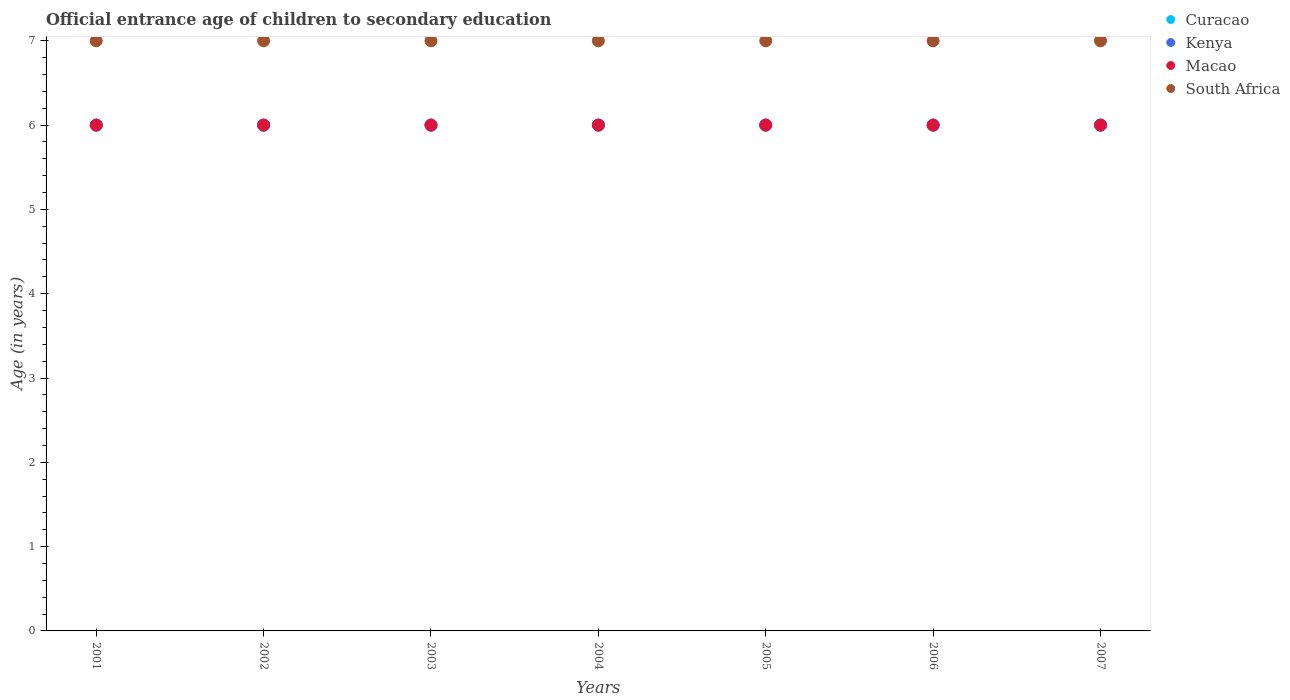How many different coloured dotlines are there?
Ensure brevity in your answer.  4. What is the secondary school starting age of children in Macao in 2005?
Offer a very short reply. 6. Across all years, what is the maximum secondary school starting age of children in Curacao?
Make the answer very short. 6. Across all years, what is the minimum secondary school starting age of children in Kenya?
Make the answer very short. 6. In which year was the secondary school starting age of children in Macao maximum?
Keep it short and to the point. 2001. What is the total secondary school starting age of children in Macao in the graph?
Your answer should be very brief. 42. What is the difference between the secondary school starting age of children in Kenya in 2001 and that in 2004?
Provide a short and direct response. 0. What is the average secondary school starting age of children in South Africa per year?
Give a very brief answer. 7. In the year 2006, what is the difference between the secondary school starting age of children in Curacao and secondary school starting age of children in Macao?
Provide a succinct answer. 0. In how many years, is the secondary school starting age of children in South Africa greater than 4.8 years?
Ensure brevity in your answer.  7. Is the difference between the secondary school starting age of children in Curacao in 2001 and 2007 greater than the difference between the secondary school starting age of children in Macao in 2001 and 2007?
Offer a very short reply. No. What is the difference between the highest and the second highest secondary school starting age of children in Kenya?
Give a very brief answer. 0. Is it the case that in every year, the sum of the secondary school starting age of children in South Africa and secondary school starting age of children in Macao  is greater than the sum of secondary school starting age of children in Kenya and secondary school starting age of children in Curacao?
Make the answer very short. Yes. Is the secondary school starting age of children in Kenya strictly greater than the secondary school starting age of children in South Africa over the years?
Provide a succinct answer. No. Is the secondary school starting age of children in Kenya strictly less than the secondary school starting age of children in Macao over the years?
Your answer should be very brief. No. Are the values on the major ticks of Y-axis written in scientific E-notation?
Your answer should be compact. No. How many legend labels are there?
Your answer should be compact. 4. What is the title of the graph?
Provide a short and direct response. Official entrance age of children to secondary education. What is the label or title of the Y-axis?
Provide a succinct answer. Age (in years). What is the Age (in years) in Curacao in 2001?
Keep it short and to the point. 6. What is the Age (in years) of South Africa in 2001?
Make the answer very short. 7. What is the Age (in years) of Curacao in 2002?
Offer a very short reply. 6. What is the Age (in years) of Kenya in 2002?
Provide a short and direct response. 6. What is the Age (in years) of South Africa in 2002?
Offer a terse response. 7. What is the Age (in years) of Curacao in 2003?
Give a very brief answer. 6. What is the Age (in years) of Macao in 2003?
Make the answer very short. 6. What is the Age (in years) of South Africa in 2004?
Your response must be concise. 7. What is the Age (in years) of Curacao in 2006?
Provide a short and direct response. 6. What is the Age (in years) in South Africa in 2006?
Your answer should be compact. 7. What is the Age (in years) of South Africa in 2007?
Keep it short and to the point. 7. Across all years, what is the maximum Age (in years) in Curacao?
Keep it short and to the point. 6. Across all years, what is the minimum Age (in years) in Macao?
Provide a short and direct response. 6. What is the total Age (in years) of Curacao in the graph?
Ensure brevity in your answer.  42. What is the total Age (in years) of Macao in the graph?
Offer a terse response. 42. What is the difference between the Age (in years) in Curacao in 2001 and that in 2002?
Give a very brief answer. 0. What is the difference between the Age (in years) in Kenya in 2001 and that in 2002?
Keep it short and to the point. 0. What is the difference between the Age (in years) in Kenya in 2001 and that in 2003?
Ensure brevity in your answer.  0. What is the difference between the Age (in years) in South Africa in 2001 and that in 2003?
Provide a succinct answer. 0. What is the difference between the Age (in years) in Macao in 2001 and that in 2004?
Provide a succinct answer. 0. What is the difference between the Age (in years) of South Africa in 2001 and that in 2004?
Give a very brief answer. 0. What is the difference between the Age (in years) of South Africa in 2001 and that in 2005?
Give a very brief answer. 0. What is the difference between the Age (in years) of Curacao in 2001 and that in 2006?
Give a very brief answer. 0. What is the difference between the Age (in years) of Kenya in 2001 and that in 2007?
Offer a terse response. 0. What is the difference between the Age (in years) in Macao in 2001 and that in 2007?
Offer a terse response. 0. What is the difference between the Age (in years) in Kenya in 2002 and that in 2003?
Offer a terse response. 0. What is the difference between the Age (in years) in Kenya in 2002 and that in 2004?
Your response must be concise. 0. What is the difference between the Age (in years) in Macao in 2002 and that in 2004?
Keep it short and to the point. 0. What is the difference between the Age (in years) in Curacao in 2002 and that in 2005?
Ensure brevity in your answer.  0. What is the difference between the Age (in years) of South Africa in 2002 and that in 2005?
Your response must be concise. 0. What is the difference between the Age (in years) in Curacao in 2002 and that in 2006?
Give a very brief answer. 0. What is the difference between the Age (in years) of Macao in 2002 and that in 2006?
Ensure brevity in your answer.  0. What is the difference between the Age (in years) in Macao in 2002 and that in 2007?
Ensure brevity in your answer.  0. What is the difference between the Age (in years) in South Africa in 2002 and that in 2007?
Your answer should be compact. 0. What is the difference between the Age (in years) of Curacao in 2003 and that in 2004?
Keep it short and to the point. 0. What is the difference between the Age (in years) of Curacao in 2003 and that in 2005?
Offer a very short reply. 0. What is the difference between the Age (in years) of Kenya in 2003 and that in 2005?
Give a very brief answer. 0. What is the difference between the Age (in years) in Macao in 2003 and that in 2005?
Provide a short and direct response. 0. What is the difference between the Age (in years) of South Africa in 2003 and that in 2005?
Offer a terse response. 0. What is the difference between the Age (in years) of Curacao in 2003 and that in 2006?
Offer a very short reply. 0. What is the difference between the Age (in years) of Macao in 2003 and that in 2007?
Your answer should be very brief. 0. What is the difference between the Age (in years) of South Africa in 2003 and that in 2007?
Make the answer very short. 0. What is the difference between the Age (in years) of Curacao in 2004 and that in 2005?
Provide a short and direct response. 0. What is the difference between the Age (in years) in Kenya in 2004 and that in 2005?
Your answer should be very brief. 0. What is the difference between the Age (in years) in Macao in 2004 and that in 2005?
Give a very brief answer. 0. What is the difference between the Age (in years) of Curacao in 2004 and that in 2006?
Ensure brevity in your answer.  0. What is the difference between the Age (in years) of Kenya in 2004 and that in 2006?
Keep it short and to the point. 0. What is the difference between the Age (in years) of Macao in 2004 and that in 2006?
Ensure brevity in your answer.  0. What is the difference between the Age (in years) of South Africa in 2004 and that in 2006?
Provide a succinct answer. 0. What is the difference between the Age (in years) of Kenya in 2004 and that in 2007?
Make the answer very short. 0. What is the difference between the Age (in years) of Curacao in 2005 and that in 2006?
Provide a succinct answer. 0. What is the difference between the Age (in years) of Kenya in 2005 and that in 2006?
Offer a very short reply. 0. What is the difference between the Age (in years) of South Africa in 2005 and that in 2006?
Keep it short and to the point. 0. What is the difference between the Age (in years) of Curacao in 2005 and that in 2007?
Your answer should be very brief. 0. What is the difference between the Age (in years) in Curacao in 2006 and that in 2007?
Keep it short and to the point. 0. What is the difference between the Age (in years) in South Africa in 2006 and that in 2007?
Your response must be concise. 0. What is the difference between the Age (in years) in Curacao in 2001 and the Age (in years) in Kenya in 2002?
Your answer should be very brief. 0. What is the difference between the Age (in years) in Curacao in 2001 and the Age (in years) in Macao in 2002?
Ensure brevity in your answer.  0. What is the difference between the Age (in years) in Kenya in 2001 and the Age (in years) in Macao in 2002?
Your answer should be very brief. 0. What is the difference between the Age (in years) of Curacao in 2001 and the Age (in years) of Kenya in 2003?
Offer a very short reply. 0. What is the difference between the Age (in years) in Curacao in 2001 and the Age (in years) in Macao in 2003?
Make the answer very short. 0. What is the difference between the Age (in years) in Macao in 2001 and the Age (in years) in South Africa in 2003?
Give a very brief answer. -1. What is the difference between the Age (in years) in Curacao in 2001 and the Age (in years) in Macao in 2004?
Provide a succinct answer. 0. What is the difference between the Age (in years) of Curacao in 2001 and the Age (in years) of South Africa in 2004?
Provide a short and direct response. -1. What is the difference between the Age (in years) in Kenya in 2001 and the Age (in years) in Macao in 2004?
Ensure brevity in your answer.  0. What is the difference between the Age (in years) of Curacao in 2001 and the Age (in years) of Kenya in 2005?
Give a very brief answer. 0. What is the difference between the Age (in years) in Kenya in 2001 and the Age (in years) in Macao in 2005?
Make the answer very short. 0. What is the difference between the Age (in years) in Macao in 2001 and the Age (in years) in South Africa in 2005?
Provide a succinct answer. -1. What is the difference between the Age (in years) in Curacao in 2001 and the Age (in years) in Macao in 2006?
Your response must be concise. 0. What is the difference between the Age (in years) of Curacao in 2001 and the Age (in years) of South Africa in 2006?
Offer a very short reply. -1. What is the difference between the Age (in years) of Kenya in 2001 and the Age (in years) of Macao in 2006?
Your answer should be very brief. 0. What is the difference between the Age (in years) in Kenya in 2001 and the Age (in years) in South Africa in 2006?
Your answer should be very brief. -1. What is the difference between the Age (in years) of Curacao in 2001 and the Age (in years) of Kenya in 2007?
Keep it short and to the point. 0. What is the difference between the Age (in years) in Curacao in 2001 and the Age (in years) in South Africa in 2007?
Your answer should be very brief. -1. What is the difference between the Age (in years) in Macao in 2001 and the Age (in years) in South Africa in 2007?
Your answer should be very brief. -1. What is the difference between the Age (in years) in Curacao in 2002 and the Age (in years) in Kenya in 2003?
Give a very brief answer. 0. What is the difference between the Age (in years) of Curacao in 2002 and the Age (in years) of Macao in 2003?
Keep it short and to the point. 0. What is the difference between the Age (in years) of Kenya in 2002 and the Age (in years) of South Africa in 2003?
Ensure brevity in your answer.  -1. What is the difference between the Age (in years) of Curacao in 2002 and the Age (in years) of Kenya in 2004?
Give a very brief answer. 0. What is the difference between the Age (in years) of Curacao in 2002 and the Age (in years) of South Africa in 2004?
Give a very brief answer. -1. What is the difference between the Age (in years) in Kenya in 2002 and the Age (in years) in Macao in 2004?
Offer a very short reply. 0. What is the difference between the Age (in years) in Macao in 2002 and the Age (in years) in South Africa in 2004?
Your answer should be very brief. -1. What is the difference between the Age (in years) of Curacao in 2002 and the Age (in years) of Kenya in 2005?
Provide a short and direct response. 0. What is the difference between the Age (in years) of Curacao in 2002 and the Age (in years) of Macao in 2005?
Your answer should be very brief. 0. What is the difference between the Age (in years) in Curacao in 2002 and the Age (in years) in South Africa in 2005?
Your answer should be compact. -1. What is the difference between the Age (in years) of Kenya in 2002 and the Age (in years) of South Africa in 2006?
Give a very brief answer. -1. What is the difference between the Age (in years) in Macao in 2002 and the Age (in years) in South Africa in 2006?
Offer a terse response. -1. What is the difference between the Age (in years) of Curacao in 2002 and the Age (in years) of South Africa in 2007?
Your answer should be very brief. -1. What is the difference between the Age (in years) of Curacao in 2003 and the Age (in years) of Kenya in 2004?
Make the answer very short. 0. What is the difference between the Age (in years) of Kenya in 2003 and the Age (in years) of South Africa in 2004?
Your answer should be compact. -1. What is the difference between the Age (in years) of Macao in 2003 and the Age (in years) of South Africa in 2004?
Provide a short and direct response. -1. What is the difference between the Age (in years) of Kenya in 2003 and the Age (in years) of Macao in 2005?
Make the answer very short. 0. What is the difference between the Age (in years) of Curacao in 2003 and the Age (in years) of Macao in 2006?
Your response must be concise. 0. What is the difference between the Age (in years) of Kenya in 2003 and the Age (in years) of Macao in 2006?
Provide a short and direct response. 0. What is the difference between the Age (in years) of Kenya in 2003 and the Age (in years) of Macao in 2007?
Give a very brief answer. 0. What is the difference between the Age (in years) in Kenya in 2003 and the Age (in years) in South Africa in 2007?
Keep it short and to the point. -1. What is the difference between the Age (in years) of Curacao in 2004 and the Age (in years) of Macao in 2005?
Ensure brevity in your answer.  0. What is the difference between the Age (in years) of Curacao in 2004 and the Age (in years) of South Africa in 2005?
Your response must be concise. -1. What is the difference between the Age (in years) in Kenya in 2004 and the Age (in years) in Macao in 2005?
Keep it short and to the point. 0. What is the difference between the Age (in years) of Kenya in 2004 and the Age (in years) of South Africa in 2005?
Give a very brief answer. -1. What is the difference between the Age (in years) of Curacao in 2004 and the Age (in years) of Kenya in 2006?
Provide a short and direct response. 0. What is the difference between the Age (in years) of Curacao in 2004 and the Age (in years) of Macao in 2006?
Provide a short and direct response. 0. What is the difference between the Age (in years) of Kenya in 2004 and the Age (in years) of South Africa in 2006?
Make the answer very short. -1. What is the difference between the Age (in years) of Curacao in 2004 and the Age (in years) of Kenya in 2007?
Offer a very short reply. 0. What is the difference between the Age (in years) in Curacao in 2004 and the Age (in years) in Macao in 2007?
Your response must be concise. 0. What is the difference between the Age (in years) of Curacao in 2004 and the Age (in years) of South Africa in 2007?
Give a very brief answer. -1. What is the difference between the Age (in years) in Kenya in 2004 and the Age (in years) in Macao in 2007?
Offer a terse response. 0. What is the difference between the Age (in years) of Macao in 2004 and the Age (in years) of South Africa in 2007?
Offer a very short reply. -1. What is the difference between the Age (in years) in Curacao in 2005 and the Age (in years) in Kenya in 2006?
Your answer should be compact. 0. What is the difference between the Age (in years) in Curacao in 2005 and the Age (in years) in Macao in 2006?
Offer a very short reply. 0. What is the difference between the Age (in years) in Kenya in 2005 and the Age (in years) in South Africa in 2006?
Your answer should be compact. -1. What is the difference between the Age (in years) in Curacao in 2005 and the Age (in years) in Macao in 2007?
Make the answer very short. 0. What is the difference between the Age (in years) in Curacao in 2005 and the Age (in years) in South Africa in 2007?
Your response must be concise. -1. What is the difference between the Age (in years) of Kenya in 2005 and the Age (in years) of South Africa in 2007?
Keep it short and to the point. -1. What is the difference between the Age (in years) of Curacao in 2006 and the Age (in years) of South Africa in 2007?
Offer a terse response. -1. What is the difference between the Age (in years) in Kenya in 2006 and the Age (in years) in South Africa in 2007?
Offer a terse response. -1. What is the average Age (in years) in Macao per year?
Make the answer very short. 6. In the year 2001, what is the difference between the Age (in years) of Kenya and Age (in years) of Macao?
Ensure brevity in your answer.  0. In the year 2001, what is the difference between the Age (in years) in Macao and Age (in years) in South Africa?
Make the answer very short. -1. In the year 2002, what is the difference between the Age (in years) in Curacao and Age (in years) in Kenya?
Offer a very short reply. 0. In the year 2002, what is the difference between the Age (in years) in Curacao and Age (in years) in South Africa?
Your answer should be very brief. -1. In the year 2002, what is the difference between the Age (in years) in Kenya and Age (in years) in South Africa?
Offer a terse response. -1. In the year 2003, what is the difference between the Age (in years) in Curacao and Age (in years) in Macao?
Your response must be concise. 0. In the year 2003, what is the difference between the Age (in years) of Curacao and Age (in years) of South Africa?
Make the answer very short. -1. In the year 2003, what is the difference between the Age (in years) in Kenya and Age (in years) in Macao?
Your answer should be very brief. 0. In the year 2004, what is the difference between the Age (in years) in Curacao and Age (in years) in Macao?
Provide a succinct answer. 0. In the year 2004, what is the difference between the Age (in years) in Curacao and Age (in years) in South Africa?
Provide a short and direct response. -1. In the year 2004, what is the difference between the Age (in years) of Kenya and Age (in years) of Macao?
Ensure brevity in your answer.  0. In the year 2004, what is the difference between the Age (in years) in Macao and Age (in years) in South Africa?
Ensure brevity in your answer.  -1. In the year 2006, what is the difference between the Age (in years) of Curacao and Age (in years) of Kenya?
Provide a succinct answer. 0. In the year 2006, what is the difference between the Age (in years) of Curacao and Age (in years) of South Africa?
Give a very brief answer. -1. In the year 2006, what is the difference between the Age (in years) in Kenya and Age (in years) in Macao?
Your answer should be very brief. 0. In the year 2006, what is the difference between the Age (in years) of Kenya and Age (in years) of South Africa?
Offer a terse response. -1. In the year 2006, what is the difference between the Age (in years) in Macao and Age (in years) in South Africa?
Provide a short and direct response. -1. In the year 2007, what is the difference between the Age (in years) of Curacao and Age (in years) of Kenya?
Ensure brevity in your answer.  0. In the year 2007, what is the difference between the Age (in years) in Curacao and Age (in years) in Macao?
Keep it short and to the point. 0. In the year 2007, what is the difference between the Age (in years) in Curacao and Age (in years) in South Africa?
Offer a very short reply. -1. In the year 2007, what is the difference between the Age (in years) in Kenya and Age (in years) in Macao?
Give a very brief answer. 0. In the year 2007, what is the difference between the Age (in years) of Kenya and Age (in years) of South Africa?
Offer a terse response. -1. What is the ratio of the Age (in years) of Macao in 2001 to that in 2002?
Keep it short and to the point. 1. What is the ratio of the Age (in years) in South Africa in 2001 to that in 2002?
Make the answer very short. 1. What is the ratio of the Age (in years) of Curacao in 2001 to that in 2003?
Provide a short and direct response. 1. What is the ratio of the Age (in years) in Macao in 2001 to that in 2003?
Your answer should be very brief. 1. What is the ratio of the Age (in years) in Curacao in 2001 to that in 2004?
Give a very brief answer. 1. What is the ratio of the Age (in years) in Kenya in 2001 to that in 2004?
Keep it short and to the point. 1. What is the ratio of the Age (in years) of Curacao in 2001 to that in 2005?
Provide a succinct answer. 1. What is the ratio of the Age (in years) in Kenya in 2001 to that in 2006?
Your response must be concise. 1. What is the ratio of the Age (in years) of Macao in 2001 to that in 2006?
Make the answer very short. 1. What is the ratio of the Age (in years) of Macao in 2001 to that in 2007?
Your response must be concise. 1. What is the ratio of the Age (in years) of Kenya in 2002 to that in 2003?
Ensure brevity in your answer.  1. What is the ratio of the Age (in years) of Macao in 2002 to that in 2003?
Offer a terse response. 1. What is the ratio of the Age (in years) in South Africa in 2002 to that in 2003?
Your response must be concise. 1. What is the ratio of the Age (in years) of Curacao in 2002 to that in 2004?
Provide a succinct answer. 1. What is the ratio of the Age (in years) in Kenya in 2002 to that in 2004?
Give a very brief answer. 1. What is the ratio of the Age (in years) in Macao in 2002 to that in 2004?
Give a very brief answer. 1. What is the ratio of the Age (in years) of South Africa in 2002 to that in 2004?
Provide a succinct answer. 1. What is the ratio of the Age (in years) in Curacao in 2002 to that in 2005?
Ensure brevity in your answer.  1. What is the ratio of the Age (in years) in Macao in 2002 to that in 2005?
Your answer should be very brief. 1. What is the ratio of the Age (in years) of South Africa in 2002 to that in 2005?
Make the answer very short. 1. What is the ratio of the Age (in years) in South Africa in 2002 to that in 2006?
Your answer should be compact. 1. What is the ratio of the Age (in years) in Curacao in 2002 to that in 2007?
Your answer should be compact. 1. What is the ratio of the Age (in years) in Kenya in 2002 to that in 2007?
Provide a short and direct response. 1. What is the ratio of the Age (in years) of Macao in 2002 to that in 2007?
Give a very brief answer. 1. What is the ratio of the Age (in years) in South Africa in 2002 to that in 2007?
Make the answer very short. 1. What is the ratio of the Age (in years) in Kenya in 2003 to that in 2004?
Offer a terse response. 1. What is the ratio of the Age (in years) of Macao in 2003 to that in 2004?
Offer a terse response. 1. What is the ratio of the Age (in years) of Kenya in 2003 to that in 2005?
Offer a very short reply. 1. What is the ratio of the Age (in years) in South Africa in 2003 to that in 2005?
Offer a very short reply. 1. What is the ratio of the Age (in years) of Kenya in 2003 to that in 2006?
Keep it short and to the point. 1. What is the ratio of the Age (in years) in Macao in 2003 to that in 2006?
Your response must be concise. 1. What is the ratio of the Age (in years) in South Africa in 2003 to that in 2006?
Your answer should be compact. 1. What is the ratio of the Age (in years) in Curacao in 2003 to that in 2007?
Provide a short and direct response. 1. What is the ratio of the Age (in years) in Kenya in 2003 to that in 2007?
Your answer should be very brief. 1. What is the ratio of the Age (in years) in South Africa in 2003 to that in 2007?
Keep it short and to the point. 1. What is the ratio of the Age (in years) of Macao in 2004 to that in 2005?
Your answer should be compact. 1. What is the ratio of the Age (in years) in Curacao in 2004 to that in 2006?
Provide a succinct answer. 1. What is the ratio of the Age (in years) in Kenya in 2004 to that in 2006?
Ensure brevity in your answer.  1. What is the ratio of the Age (in years) in South Africa in 2004 to that in 2006?
Offer a very short reply. 1. What is the ratio of the Age (in years) in Kenya in 2004 to that in 2007?
Your answer should be compact. 1. What is the ratio of the Age (in years) in Curacao in 2005 to that in 2006?
Provide a succinct answer. 1. What is the ratio of the Age (in years) in Kenya in 2005 to that in 2006?
Your answer should be very brief. 1. What is the ratio of the Age (in years) of Macao in 2005 to that in 2006?
Offer a terse response. 1. What is the ratio of the Age (in years) in South Africa in 2005 to that in 2007?
Ensure brevity in your answer.  1. What is the ratio of the Age (in years) in Curacao in 2006 to that in 2007?
Give a very brief answer. 1. What is the ratio of the Age (in years) of Macao in 2006 to that in 2007?
Your response must be concise. 1. What is the difference between the highest and the second highest Age (in years) of Macao?
Your response must be concise. 0. What is the difference between the highest and the lowest Age (in years) in South Africa?
Offer a very short reply. 0. 